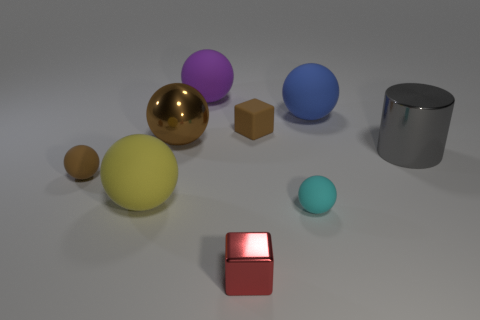Subtract all cyan spheres. How many spheres are left? 5 Subtract all small brown balls. How many balls are left? 5 Subtract all gray spheres. Subtract all yellow cylinders. How many spheres are left? 6 Subtract all spheres. How many objects are left? 3 Subtract 0 purple cubes. How many objects are left? 9 Subtract all large red balls. Subtract all large blue rubber balls. How many objects are left? 8 Add 8 large purple balls. How many large purple balls are left? 9 Add 6 large cyan metal objects. How many large cyan metal objects exist? 6 